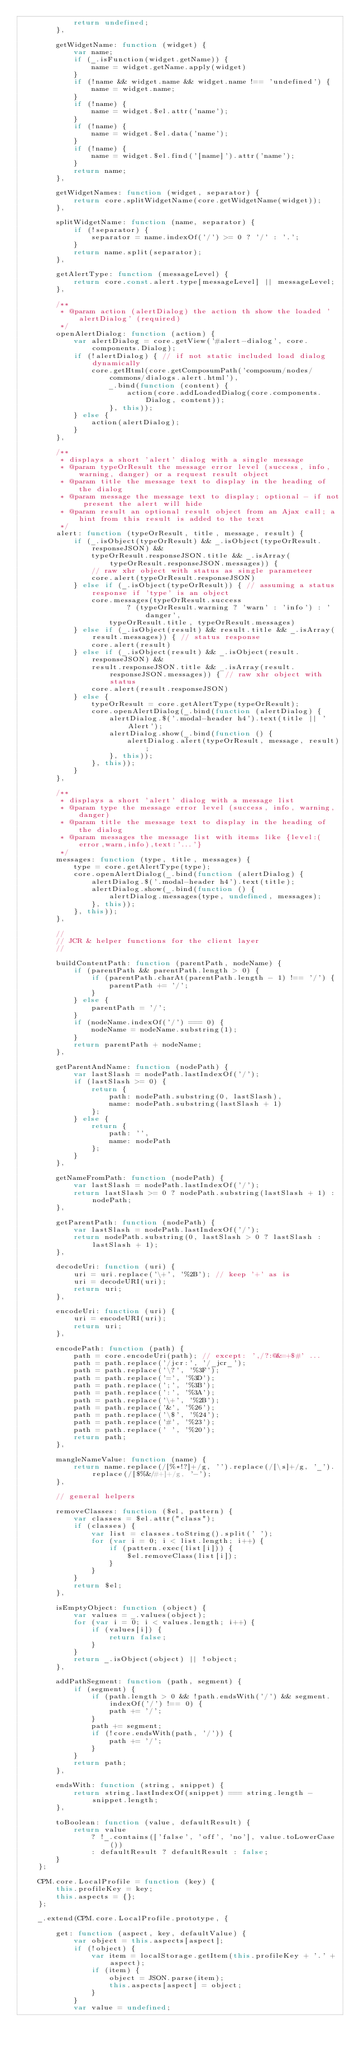Convert code to text. <code><loc_0><loc_0><loc_500><loc_500><_JavaScript_>            return undefined;
        },

        getWidgetName: function (widget) {
            var name;
            if (_.isFunction(widget.getName)) {
                name = widget.getName.apply(widget)
            }
            if (!name && widget.name && widget.name !== 'undefined') {
                name = widget.name;
            }
            if (!name) {
                name = widget.$el.attr('name');
            }
            if (!name) {
                name = widget.$el.data('name');
            }
            if (!name) {
                name = widget.$el.find('[name]').attr('name');
            }
            return name;
        },

        getWidgetNames: function (widget, separator) {
            return core.splitWidgetName(core.getWidgetName(widget));
        },

        splitWidgetName: function (name, separator) {
            if (!separator) {
                separator = name.indexOf('/') >= 0 ? '/' : '.';
            }
            return name.split(separator);
        },

        getAlertType: function (messageLevel) {
            return core.const.alert.type[messageLevel] || messageLevel;
        },

        /**
         * @param action (alertDialog) the action th show the loaded 'alertDialog' (required)
         */
        openAlertDialog: function (action) {
            var alertDialog = core.getView('#alert-dialog', core.components.Dialog);
            if (!alertDialog) { // if not static included load dialog dynamically
                core.getHtml(core.getComposumPath('composum/nodes/commons/dialogs.alert.html'),
                    _.bind(function (content) {
                        action(core.addLoadedDialog(core.components.Dialog, content));
                    }, this));
            } else {
                action(alertDialog);
            }
        },

        /**
         * displays a short 'alert' dialog with a single message
         * @param typeOrResult the message error level (success, info, warning, danger) or a request result object
         * @param title the message text to display in the heading of the dialog
         * @param message the message text to display; optional - if not present the alert will hide
         * @param result an optional result object from an Ajax call; a hint from this result is added to the text
         */
        alert: function (typeOrResult, title, message, result) {
            if (_.isObject(typeOrResult) && _.isObject(typeOrResult.responseJSON) &&
                typeOrResult.responseJSON.title && _.isArray(typeOrResult.responseJSON.messages)) {
                // raw xhr object with status as single parameteer
                core.alert(typeOrResult.responseJSON)
            } else if (_.isObject(typeOrResult)) { // assuming a status response if 'type' is an object
                core.messages(typeOrResult.success
                        ? (typeOrResult.warning ? 'warn' : 'info') : 'danger',
                    typeOrResult.title, typeOrResult.messages)
            } else if (_.isObject(result) && result.title && _.isArray(result.messages)) { // status response
                core.alert(result)
            } else if (_.isObject(result) && _.isObject(result.responseJSON) &&
                result.responseJSON.title && _.isArray(result.responseJSON.messages)) { // raw xhr object with status
                core.alert(result.responseJSON)
            } else {
                typeOrResult = core.getAlertType(typeOrResult);
                core.openAlertDialog(_.bind(function (alertDialog) {
                    alertDialog.$('.modal-header h4').text(title || 'Alert');
                    alertDialog.show(_.bind(function () {
                        alertDialog.alert(typeOrResult, message, result);
                    }, this));
                }, this));
            }
        },

        /**
         * displays a short 'alert' dialog with a message list
         * @param type the message error level (success, info, warning, danger)
         * @param title the message text to display in the heading of the dialog
         * @param messages the message list with items like {level:(error,warn,info),text:'...'}
         */
        messages: function (type, title, messages) {
            type = core.getAlertType(type);
            core.openAlertDialog(_.bind(function (alertDialog) {
                alertDialog.$('.modal-header h4').text(title);
                alertDialog.show(_.bind(function () {
                    alertDialog.messages(type, undefined, messages);
                }, this));
            }, this));
        },

        //
        // JCR & helper functions for the client layer
        //

        buildContentPath: function (parentPath, nodeName) {
            if (parentPath && parentPath.length > 0) {
                if (parentPath.charAt(parentPath.length - 1) !== '/') {
                    parentPath += '/';
                }
            } else {
                parentPath = '/';
            }
            if (nodeName.indexOf('/') === 0) {
                nodeName = nodeName.substring(1);
            }
            return parentPath + nodeName;
        },

        getParentAndName: function (nodePath) {
            var lastSlash = nodePath.lastIndexOf('/');
            if (lastSlash >= 0) {
                return {
                    path: nodePath.substring(0, lastSlash),
                    name: nodePath.substring(lastSlash + 1)
                };
            } else {
                return {
                    path: '',
                    name: nodePath
                };
            }
        },

        getNameFromPath: function (nodePath) {
            var lastSlash = nodePath.lastIndexOf('/');
            return lastSlash >= 0 ? nodePath.substring(lastSlash + 1) : nodePath;
        },

        getParentPath: function (nodePath) {
            var lastSlash = nodePath.lastIndexOf('/');
            return nodePath.substring(0, lastSlash > 0 ? lastSlash : lastSlash + 1);
        },

        decodeUri: function (uri) {
            uri = uri.replace('\+', '%2B'); // keep '+' as is
            uri = decodeURI(uri);
            return uri;
        },

        encodeUri: function (uri) {
            uri = encodeURI(uri);
            return uri;
        },

        encodePath: function (path) {
            path = core.encodeUri(path); // except: ',/?:@&=+$#' ...
            path = path.replace('/jcr:', '/_jcr_');
            path = path.replace('\?', '%3F');
            path = path.replace('=', '%3D');
            path = path.replace(';', '%3B');
            path = path.replace(':', '%3A');
            path = path.replace('\+', '%2B');
            path = path.replace('&', '%26');
            path = path.replace('\$', '%24');
            path = path.replace('#', '%23');
            path = path.replace(' ', '%20');
            return path;
        },

        mangleNameValue: function (name) {
            return name.replace(/[%*!?]+/g, '').replace(/[\s]+/g, '_').replace(/[$%&/#+]+/g, '-');
        },

        // general helpers

        removeClasses: function ($el, pattern) {
            var classes = $el.attr("class");
            if (classes) {
                var list = classes.toString().split(' ');
                for (var i = 0; i < list.length; i++) {
                    if (pattern.exec(list[i])) {
                        $el.removeClass(list[i]);
                    }
                }
            }
            return $el;
        },

        isEmptyObject: function (object) {
            var values = _.values(object);
            for (var i = 0; i < values.length; i++) {
                if (values[i]) {
                    return false;
                }
            }
            return _.isObject(object) || !object;
        },

        addPathSegment: function (path, segment) {
            if (segment) {
                if (path.length > 0 && !path.endsWith('/') && segment.indexOf('/') !== 0) {
                    path += '/';
                }
                path += segment;
                if (!core.endsWith(path, '/')) {
                    path += '/';
                }
            }
            return path;
        },

        endsWith: function (string, snippet) {
            return string.lastIndexOf(snippet) === string.length - snippet.length;
        },

        toBoolean: function (value, defaultResult) {
            return value
                ? !_.contains(['false', 'off', 'no'], value.toLowerCase())
                : defaultResult ? defaultResult : false;
        }
    };

    CPM.core.LocalProfile = function (key) {
        this.profileKey = key;
        this.aspects = {};
    };

    _.extend(CPM.core.LocalProfile.prototype, {

        get: function (aspect, key, defaultValue) {
            var object = this.aspects[aspect];
            if (!object) {
                var item = localStorage.getItem(this.profileKey + '.' + aspect);
                if (item) {
                    object = JSON.parse(item);
                    this.aspects[aspect] = object;
                }
            }
            var value = undefined;</code> 